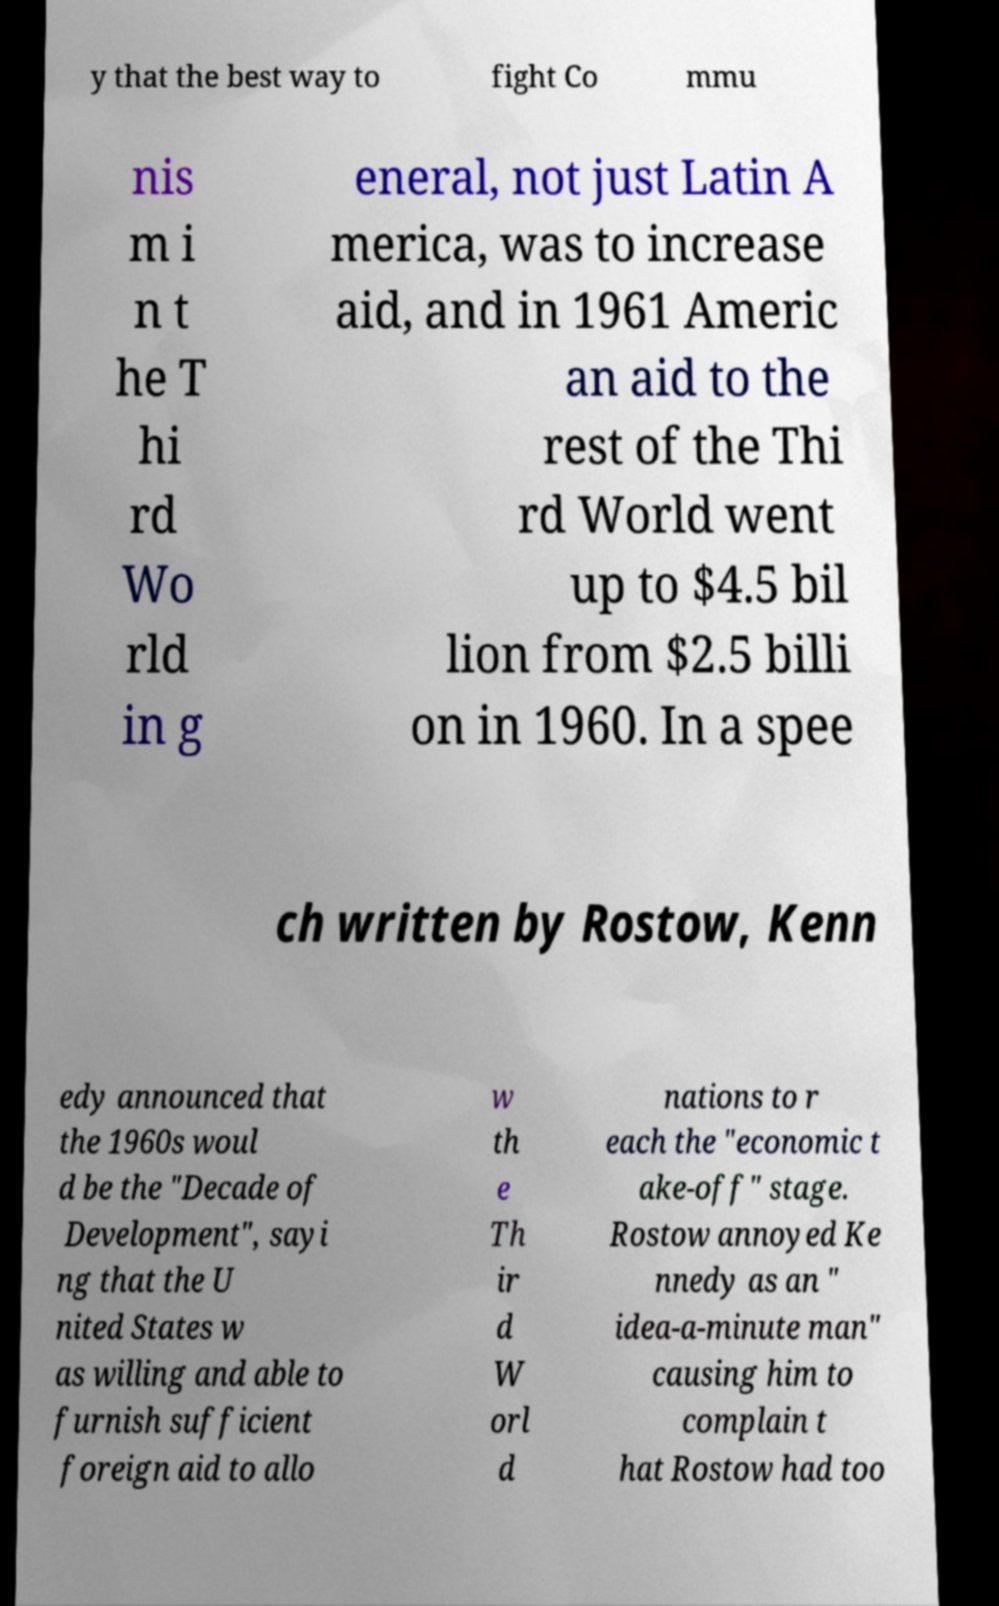I need the written content from this picture converted into text. Can you do that? y that the best way to fight Co mmu nis m i n t he T hi rd Wo rld in g eneral, not just Latin A merica, was to increase aid, and in 1961 Americ an aid to the rest of the Thi rd World went up to $4.5 bil lion from $2.5 billi on in 1960. In a spee ch written by Rostow, Kenn edy announced that the 1960s woul d be the "Decade of Development", sayi ng that the U nited States w as willing and able to furnish sufficient foreign aid to allo w th e Th ir d W orl d nations to r each the "economic t ake-off" stage. Rostow annoyed Ke nnedy as an " idea-a-minute man" causing him to complain t hat Rostow had too 